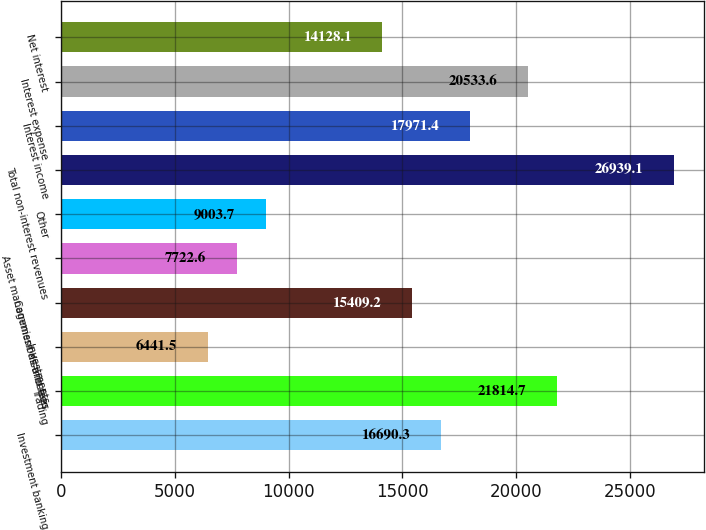<chart> <loc_0><loc_0><loc_500><loc_500><bar_chart><fcel>Investment banking<fcel>Trading<fcel>Investments<fcel>Commissions and fees<fcel>Asset management distribution<fcel>Other<fcel>Total non-interest revenues<fcel>Interest income<fcel>Interest expense<fcel>Net interest<nl><fcel>16690.3<fcel>21814.7<fcel>6441.5<fcel>15409.2<fcel>7722.6<fcel>9003.7<fcel>26939.1<fcel>17971.4<fcel>20533.6<fcel>14128.1<nl></chart> 